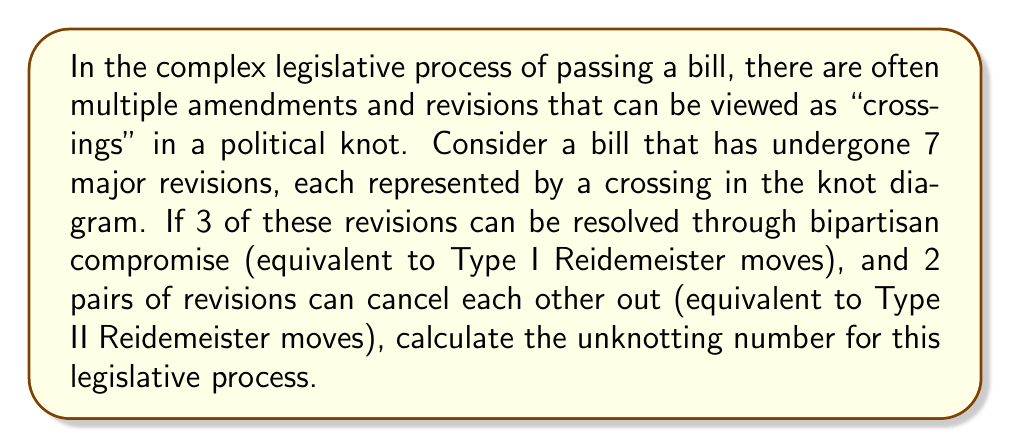Give your solution to this math problem. To solve this problem, we'll follow these steps:

1) First, let's recall that the unknotting number is the minimum number of crossing changes needed to transform a knot into the unknot.

2) We start with 7 crossings (major revisions):
   $$\text{Initial crossings} = 7$$

3) 3 revisions can be resolved through bipartisan compromise. These are equivalent to Type I Reidemeister moves, which remove a twist in the knot. Each of these reduces the number of crossings by 1:
   $$\text{Crossings after Type I moves} = 7 - 3 = 4$$

4) 2 pairs of revisions can cancel each other out. These are equivalent to Type II Reidemeister moves, which remove two crossings at once. We have 2 such pairs, so this reduces the crossings by 4:
   $$\text{Crossings after Type II moves} = 4 - 4 = 0$$

5) After these simplifications, we're left with the unknot (0 crossings). This means we've successfully "unknotted" the legislative process without needing any additional crossing changes.

6) Therefore, the unknotting number is 0, as we were able to simplify the knot to the unknot using only Reidemeister moves, without needing to change any crossings.
Answer: 0 